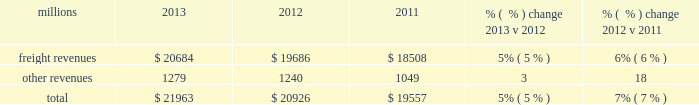F0b7 financial expectations 2013 we are cautious about the economic environment , but , assuming that industrial production grows approximately 3% ( 3 % ) as projected , volume should exceed 2013 levels .
Even with no volume growth , we expect earnings to exceed 2013 earnings , generated by core pricing gains , on-going network improvements and productivity initiatives .
We expect that free cash flow for 2014 will be lower than 2013 as higher cash from operations will be more than offset by additional cash of approximately $ 400 million that will be used to pay income taxes that were previously deferred through bonus depreciation , increased capital spend and higher dividend payments .
Results of operations operating revenues millions 2013 2012 2011 % (  % ) change 2013 v 2012 % (  % ) change 2012 v 2011 .
We generate freight revenues by transporting freight or other materials from our six commodity groups .
Freight revenues vary with volume ( carloads ) and arc .
Changes in price , traffic mix and fuel surcharges drive arc .
We provide some of our customers with contractual incentives for meeting or exceeding specified cumulative volumes or shipping to and from specific locations , which we record as reductions to freight revenues based on the actual or projected future shipments .
We recognize freight revenues as shipments move from origin to destination .
We allocate freight revenues between reporting periods based on the relative transit time in each reporting period and recognize expenses as we incur them .
Other revenues include revenues earned by our subsidiaries , revenues from our commuter rail operations , and accessorial revenues , which we earn when customers retain equipment owned or controlled by us or when we perform additional services such as switching or storage .
We recognize other revenues as we perform services or meet contractual obligations .
Freight revenues from five of our six commodity groups increased during 2013 compared to 2012 .
Revenue from agricultural products was down slightly compared to 2012 .
Arc increased 5% ( 5 % ) , driven by core pricing gains , shifts in business mix and an automotive logistics management arrangement .
Volume was essentially flat year over year as growth in automotives , frac sand , crude oil and domestic intermodal offset declines in coal , international intermodal and grain shipments .
Freight revenues from four of our six commodity groups increased during 2012 compared to 2011 .
Revenues from coal and agricultural products declined during the year .
Our franchise diversity allowed us to take advantage of growth from shale-related markets ( crude oil , frac sand and pipe ) and strong automotive manufacturing , which offset volume declines from coal and agricultural products .
Arc increased 7% ( 7 % ) , driven by core pricing gains and higher fuel cost recoveries .
Improved fuel recovery provisions and higher fuel prices , including the lag effect of our programs ( surcharges trail fluctuations in fuel price by approximately two months ) , combined to increase revenues from fuel surcharges .
Our fuel surcharge programs generated freight revenues of $ 2.6 billion , $ 2.6 billion , and $ 2.2 billion in 2013 , 2012 , and 2011 , respectively .
Fuel surcharge in 2013 was essentially flat versus 2012 as lower fuel price offset improved fuel recovery provisions and the lag effect of our programs ( surcharges trail fluctuations in fuel price by approximately two months ) .
Rising fuel prices and more shipments subject to fuel surcharges drove the increase from 2011 to 2012 .
In 2013 , other revenue increased from 2012 due primarily to miscellaneous contract revenue and higher revenues at our subsidiaries that broker intermodal and automotive services .
In 2012 , other revenues increased from 2011 due primarily to higher revenues at our subsidiaries that broker intermodal and automotive services .
Assessorial revenues also increased in 2012 due to container revenue related to an increase in intermodal shipments. .
What was the percentage change in fuel surcharge revenues from 2011 to 2012? 
Computations: ((2.6 - 2.2) / 2.2)
Answer: 0.18182. 